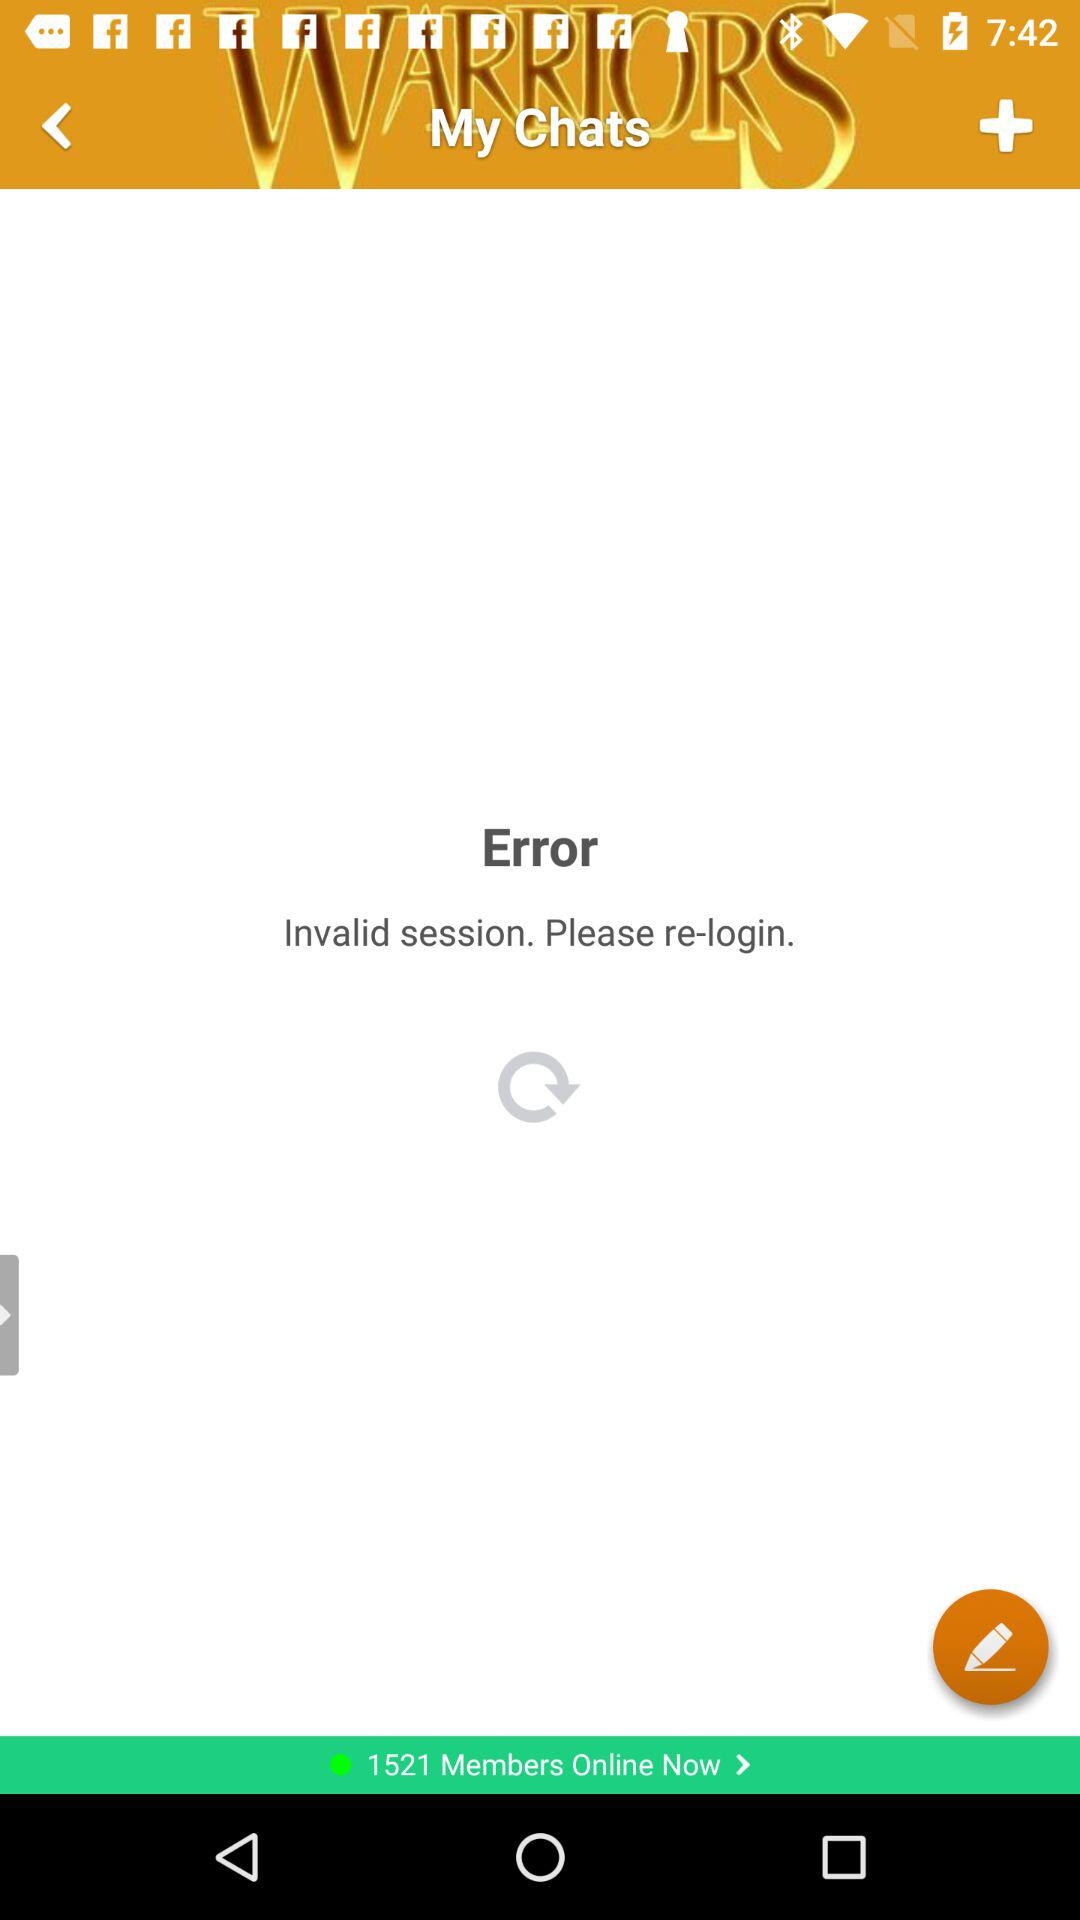How many members are online now? There are 1521 members online now. 